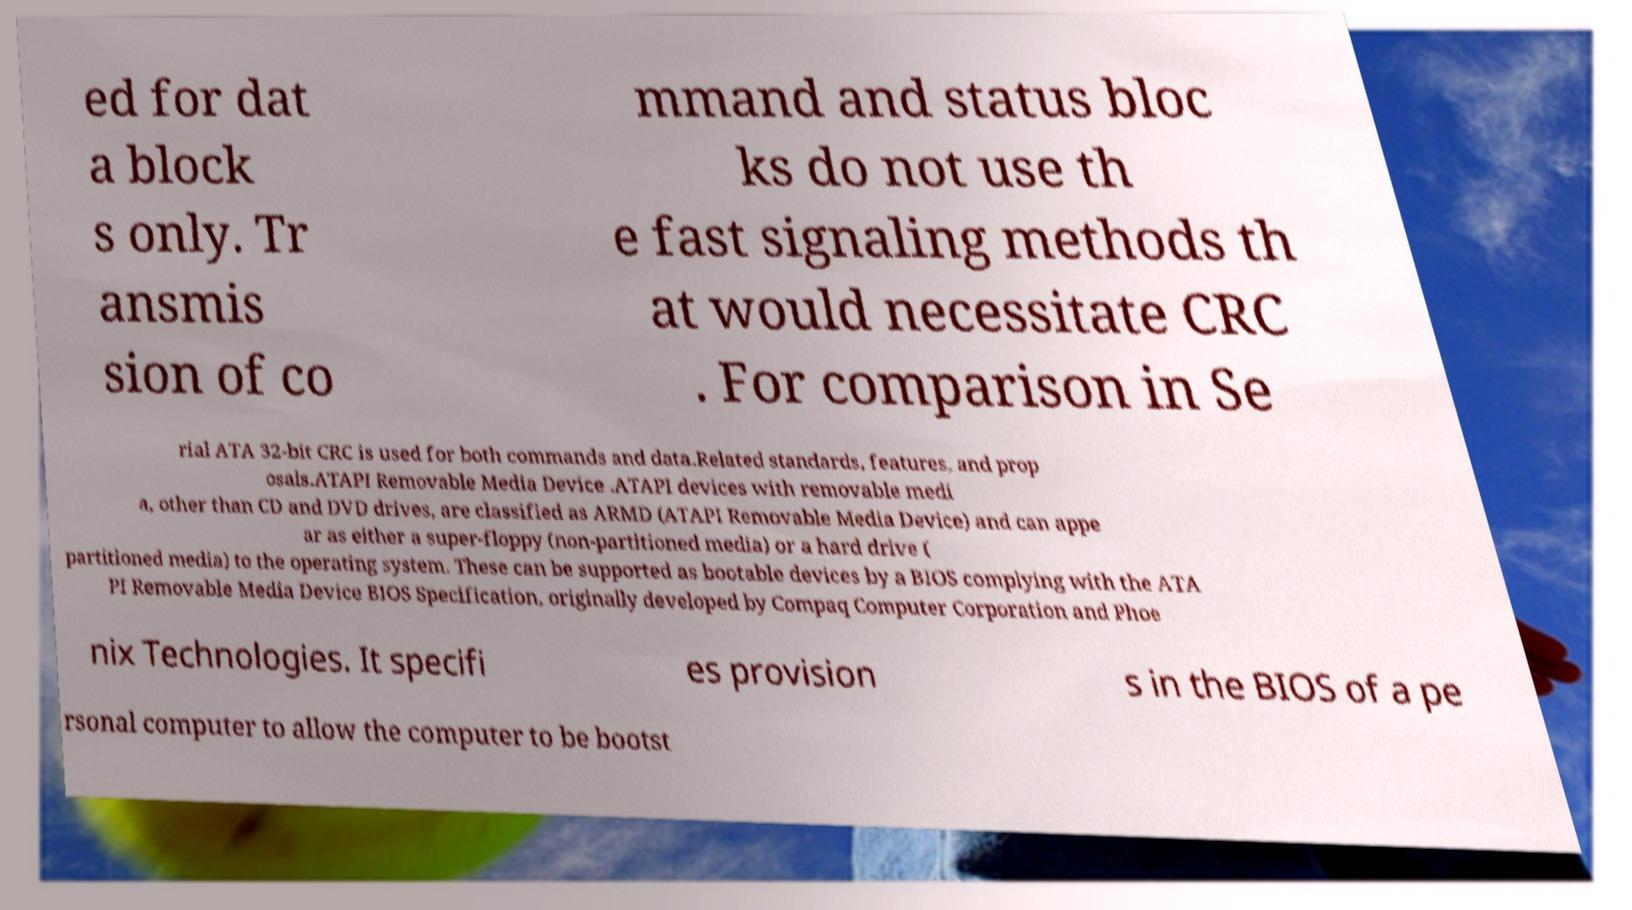There's text embedded in this image that I need extracted. Can you transcribe it verbatim? ed for dat a block s only. Tr ansmis sion of co mmand and status bloc ks do not use th e fast signaling methods th at would necessitate CRC . For comparison in Se rial ATA 32-bit CRC is used for both commands and data.Related standards, features, and prop osals.ATAPI Removable Media Device .ATAPI devices with removable medi a, other than CD and DVD drives, are classified as ARMD (ATAPI Removable Media Device) and can appe ar as either a super-floppy (non-partitioned media) or a hard drive ( partitioned media) to the operating system. These can be supported as bootable devices by a BIOS complying with the ATA PI Removable Media Device BIOS Specification, originally developed by Compaq Computer Corporation and Phoe nix Technologies. It specifi es provision s in the BIOS of a pe rsonal computer to allow the computer to be bootst 